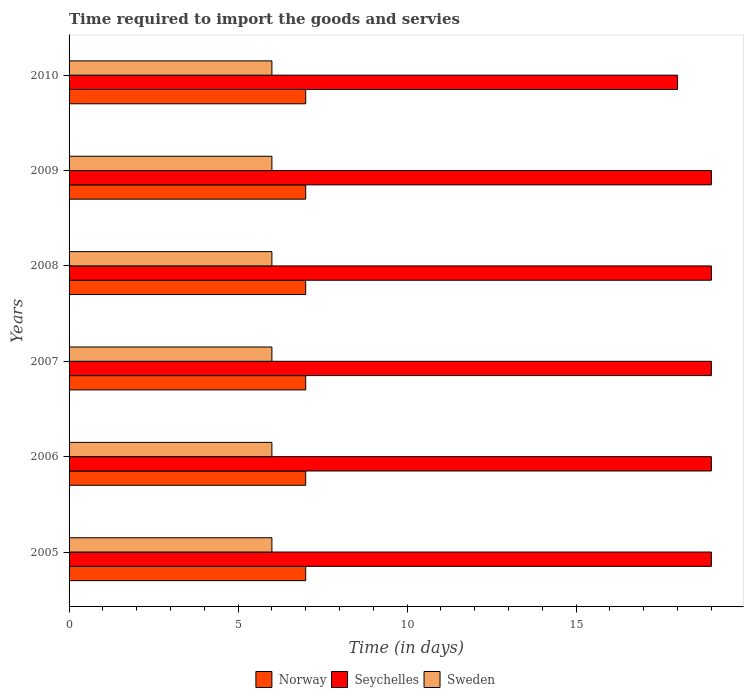Are the number of bars on each tick of the Y-axis equal?
Offer a very short reply. Yes. How many bars are there on the 4th tick from the top?
Offer a very short reply. 3. What is the label of the 6th group of bars from the top?
Your answer should be compact. 2005. Across all years, what is the maximum number of days required to import the goods and services in Seychelles?
Ensure brevity in your answer.  19. Across all years, what is the minimum number of days required to import the goods and services in Norway?
Your answer should be compact. 7. In which year was the number of days required to import the goods and services in Sweden maximum?
Your response must be concise. 2005. What is the total number of days required to import the goods and services in Sweden in the graph?
Your answer should be compact. 36. What is the difference between the number of days required to import the goods and services in Norway in 2005 and the number of days required to import the goods and services in Seychelles in 2008?
Your answer should be compact. -12. In the year 2007, what is the difference between the number of days required to import the goods and services in Norway and number of days required to import the goods and services in Seychelles?
Ensure brevity in your answer.  -12. What is the ratio of the number of days required to import the goods and services in Seychelles in 2005 to that in 2008?
Keep it short and to the point. 1. Is the difference between the number of days required to import the goods and services in Norway in 2005 and 2006 greater than the difference between the number of days required to import the goods and services in Seychelles in 2005 and 2006?
Your response must be concise. No. What is the difference between the highest and the second highest number of days required to import the goods and services in Seychelles?
Your answer should be very brief. 0. In how many years, is the number of days required to import the goods and services in Seychelles greater than the average number of days required to import the goods and services in Seychelles taken over all years?
Your answer should be compact. 5. Is the sum of the number of days required to import the goods and services in Sweden in 2007 and 2009 greater than the maximum number of days required to import the goods and services in Norway across all years?
Offer a very short reply. Yes. What does the 3rd bar from the top in 2007 represents?
Provide a succinct answer. Norway. What is the difference between two consecutive major ticks on the X-axis?
Offer a terse response. 5. Where does the legend appear in the graph?
Your response must be concise. Bottom center. How many legend labels are there?
Offer a terse response. 3. What is the title of the graph?
Offer a terse response. Time required to import the goods and servies. Does "Korea (Democratic)" appear as one of the legend labels in the graph?
Your answer should be very brief. No. What is the label or title of the X-axis?
Offer a terse response. Time (in days). What is the Time (in days) in Seychelles in 2006?
Provide a short and direct response. 19. What is the Time (in days) of Seychelles in 2007?
Provide a short and direct response. 19. What is the Time (in days) in Seychelles in 2008?
Provide a short and direct response. 19. What is the Time (in days) in Sweden in 2009?
Offer a terse response. 6. What is the Time (in days) of Norway in 2010?
Give a very brief answer. 7. What is the Time (in days) of Seychelles in 2010?
Ensure brevity in your answer.  18. Across all years, what is the maximum Time (in days) of Norway?
Your answer should be very brief. 7. Across all years, what is the maximum Time (in days) of Seychelles?
Offer a terse response. 19. Across all years, what is the minimum Time (in days) of Seychelles?
Provide a short and direct response. 18. Across all years, what is the minimum Time (in days) in Sweden?
Your answer should be compact. 6. What is the total Time (in days) of Seychelles in the graph?
Give a very brief answer. 113. What is the difference between the Time (in days) in Norway in 2005 and that in 2006?
Provide a short and direct response. 0. What is the difference between the Time (in days) in Sweden in 2005 and that in 2006?
Your response must be concise. 0. What is the difference between the Time (in days) of Norway in 2005 and that in 2007?
Offer a terse response. 0. What is the difference between the Time (in days) in Sweden in 2005 and that in 2007?
Provide a short and direct response. 0. What is the difference between the Time (in days) in Sweden in 2005 and that in 2008?
Offer a very short reply. 0. What is the difference between the Time (in days) in Norway in 2005 and that in 2009?
Provide a succinct answer. 0. What is the difference between the Time (in days) in Seychelles in 2005 and that in 2009?
Offer a terse response. 0. What is the difference between the Time (in days) of Norway in 2005 and that in 2010?
Offer a terse response. 0. What is the difference between the Time (in days) in Norway in 2006 and that in 2007?
Provide a succinct answer. 0. What is the difference between the Time (in days) in Sweden in 2006 and that in 2007?
Make the answer very short. 0. What is the difference between the Time (in days) in Norway in 2006 and that in 2008?
Offer a terse response. 0. What is the difference between the Time (in days) in Seychelles in 2006 and that in 2008?
Offer a very short reply. 0. What is the difference between the Time (in days) of Seychelles in 2006 and that in 2009?
Make the answer very short. 0. What is the difference between the Time (in days) in Seychelles in 2006 and that in 2010?
Make the answer very short. 1. What is the difference between the Time (in days) in Seychelles in 2007 and that in 2009?
Your answer should be compact. 0. What is the difference between the Time (in days) in Sweden in 2007 and that in 2009?
Your response must be concise. 0. What is the difference between the Time (in days) in Norway in 2007 and that in 2010?
Keep it short and to the point. 0. What is the difference between the Time (in days) in Seychelles in 2007 and that in 2010?
Your answer should be very brief. 1. What is the difference between the Time (in days) in Sweden in 2007 and that in 2010?
Provide a succinct answer. 0. What is the difference between the Time (in days) of Norway in 2008 and that in 2009?
Your answer should be very brief. 0. What is the difference between the Time (in days) of Seychelles in 2008 and that in 2009?
Provide a succinct answer. 0. What is the difference between the Time (in days) in Seychelles in 2008 and that in 2010?
Your answer should be very brief. 1. What is the difference between the Time (in days) of Sweden in 2008 and that in 2010?
Provide a succinct answer. 0. What is the difference between the Time (in days) of Norway in 2009 and that in 2010?
Your response must be concise. 0. What is the difference between the Time (in days) of Norway in 2005 and the Time (in days) of Seychelles in 2006?
Ensure brevity in your answer.  -12. What is the difference between the Time (in days) of Norway in 2005 and the Time (in days) of Seychelles in 2007?
Your answer should be compact. -12. What is the difference between the Time (in days) in Norway in 2005 and the Time (in days) in Sweden in 2007?
Make the answer very short. 1. What is the difference between the Time (in days) in Norway in 2005 and the Time (in days) in Seychelles in 2008?
Your response must be concise. -12. What is the difference between the Time (in days) of Norway in 2005 and the Time (in days) of Sweden in 2008?
Give a very brief answer. 1. What is the difference between the Time (in days) in Norway in 2005 and the Time (in days) in Seychelles in 2009?
Offer a very short reply. -12. What is the difference between the Time (in days) of Norway in 2005 and the Time (in days) of Sweden in 2009?
Make the answer very short. 1. What is the difference between the Time (in days) of Norway in 2005 and the Time (in days) of Seychelles in 2010?
Your answer should be very brief. -11. What is the difference between the Time (in days) of Seychelles in 2005 and the Time (in days) of Sweden in 2010?
Make the answer very short. 13. What is the difference between the Time (in days) in Norway in 2006 and the Time (in days) in Seychelles in 2007?
Ensure brevity in your answer.  -12. What is the difference between the Time (in days) in Norway in 2006 and the Time (in days) in Seychelles in 2008?
Provide a short and direct response. -12. What is the difference between the Time (in days) of Norway in 2006 and the Time (in days) of Sweden in 2009?
Make the answer very short. 1. What is the difference between the Time (in days) in Norway in 2006 and the Time (in days) in Seychelles in 2010?
Offer a terse response. -11. What is the difference between the Time (in days) of Seychelles in 2006 and the Time (in days) of Sweden in 2010?
Make the answer very short. 13. What is the difference between the Time (in days) of Norway in 2007 and the Time (in days) of Seychelles in 2008?
Provide a succinct answer. -12. What is the difference between the Time (in days) in Seychelles in 2007 and the Time (in days) in Sweden in 2008?
Your response must be concise. 13. What is the difference between the Time (in days) of Norway in 2007 and the Time (in days) of Seychelles in 2010?
Your answer should be very brief. -11. What is the difference between the Time (in days) of Seychelles in 2007 and the Time (in days) of Sweden in 2010?
Provide a short and direct response. 13. What is the difference between the Time (in days) in Norway in 2008 and the Time (in days) in Sweden in 2009?
Your answer should be very brief. 1. What is the difference between the Time (in days) of Seychelles in 2008 and the Time (in days) of Sweden in 2009?
Provide a succinct answer. 13. What is the difference between the Time (in days) of Norway in 2008 and the Time (in days) of Seychelles in 2010?
Make the answer very short. -11. What is the difference between the Time (in days) in Seychelles in 2008 and the Time (in days) in Sweden in 2010?
Make the answer very short. 13. What is the difference between the Time (in days) of Norway in 2009 and the Time (in days) of Seychelles in 2010?
Your response must be concise. -11. What is the average Time (in days) of Norway per year?
Provide a succinct answer. 7. What is the average Time (in days) in Seychelles per year?
Give a very brief answer. 18.83. In the year 2005, what is the difference between the Time (in days) in Norway and Time (in days) in Sweden?
Give a very brief answer. 1. In the year 2005, what is the difference between the Time (in days) of Seychelles and Time (in days) of Sweden?
Your answer should be very brief. 13. In the year 2006, what is the difference between the Time (in days) in Seychelles and Time (in days) in Sweden?
Keep it short and to the point. 13. In the year 2007, what is the difference between the Time (in days) of Norway and Time (in days) of Seychelles?
Your response must be concise. -12. In the year 2008, what is the difference between the Time (in days) in Norway and Time (in days) in Sweden?
Provide a short and direct response. 1. In the year 2009, what is the difference between the Time (in days) in Norway and Time (in days) in Seychelles?
Offer a very short reply. -12. In the year 2009, what is the difference between the Time (in days) of Norway and Time (in days) of Sweden?
Your response must be concise. 1. In the year 2009, what is the difference between the Time (in days) in Seychelles and Time (in days) in Sweden?
Offer a terse response. 13. In the year 2010, what is the difference between the Time (in days) of Norway and Time (in days) of Sweden?
Make the answer very short. 1. In the year 2010, what is the difference between the Time (in days) in Seychelles and Time (in days) in Sweden?
Offer a terse response. 12. What is the ratio of the Time (in days) of Sweden in 2005 to that in 2006?
Offer a very short reply. 1. What is the ratio of the Time (in days) in Sweden in 2005 to that in 2007?
Your response must be concise. 1. What is the ratio of the Time (in days) of Norway in 2005 to that in 2008?
Give a very brief answer. 1. What is the ratio of the Time (in days) in Sweden in 2005 to that in 2009?
Your answer should be compact. 1. What is the ratio of the Time (in days) in Seychelles in 2005 to that in 2010?
Your answer should be very brief. 1.06. What is the ratio of the Time (in days) of Norway in 2006 to that in 2008?
Provide a short and direct response. 1. What is the ratio of the Time (in days) in Seychelles in 2006 to that in 2008?
Offer a terse response. 1. What is the ratio of the Time (in days) in Sweden in 2006 to that in 2008?
Ensure brevity in your answer.  1. What is the ratio of the Time (in days) of Norway in 2006 to that in 2009?
Your answer should be very brief. 1. What is the ratio of the Time (in days) of Seychelles in 2006 to that in 2010?
Offer a very short reply. 1.06. What is the ratio of the Time (in days) in Sweden in 2006 to that in 2010?
Keep it short and to the point. 1. What is the ratio of the Time (in days) of Seychelles in 2007 to that in 2008?
Your answer should be very brief. 1. What is the ratio of the Time (in days) in Norway in 2007 to that in 2009?
Your answer should be very brief. 1. What is the ratio of the Time (in days) in Seychelles in 2007 to that in 2010?
Ensure brevity in your answer.  1.06. What is the ratio of the Time (in days) in Sweden in 2007 to that in 2010?
Make the answer very short. 1. What is the ratio of the Time (in days) of Norway in 2008 to that in 2009?
Make the answer very short. 1. What is the ratio of the Time (in days) in Seychelles in 2008 to that in 2009?
Your response must be concise. 1. What is the ratio of the Time (in days) of Norway in 2008 to that in 2010?
Your answer should be compact. 1. What is the ratio of the Time (in days) of Seychelles in 2008 to that in 2010?
Offer a very short reply. 1.06. What is the ratio of the Time (in days) in Seychelles in 2009 to that in 2010?
Offer a very short reply. 1.06. What is the ratio of the Time (in days) in Sweden in 2009 to that in 2010?
Keep it short and to the point. 1. What is the difference between the highest and the second highest Time (in days) in Norway?
Your answer should be very brief. 0. What is the difference between the highest and the lowest Time (in days) of Norway?
Your answer should be compact. 0. What is the difference between the highest and the lowest Time (in days) in Sweden?
Offer a very short reply. 0. 